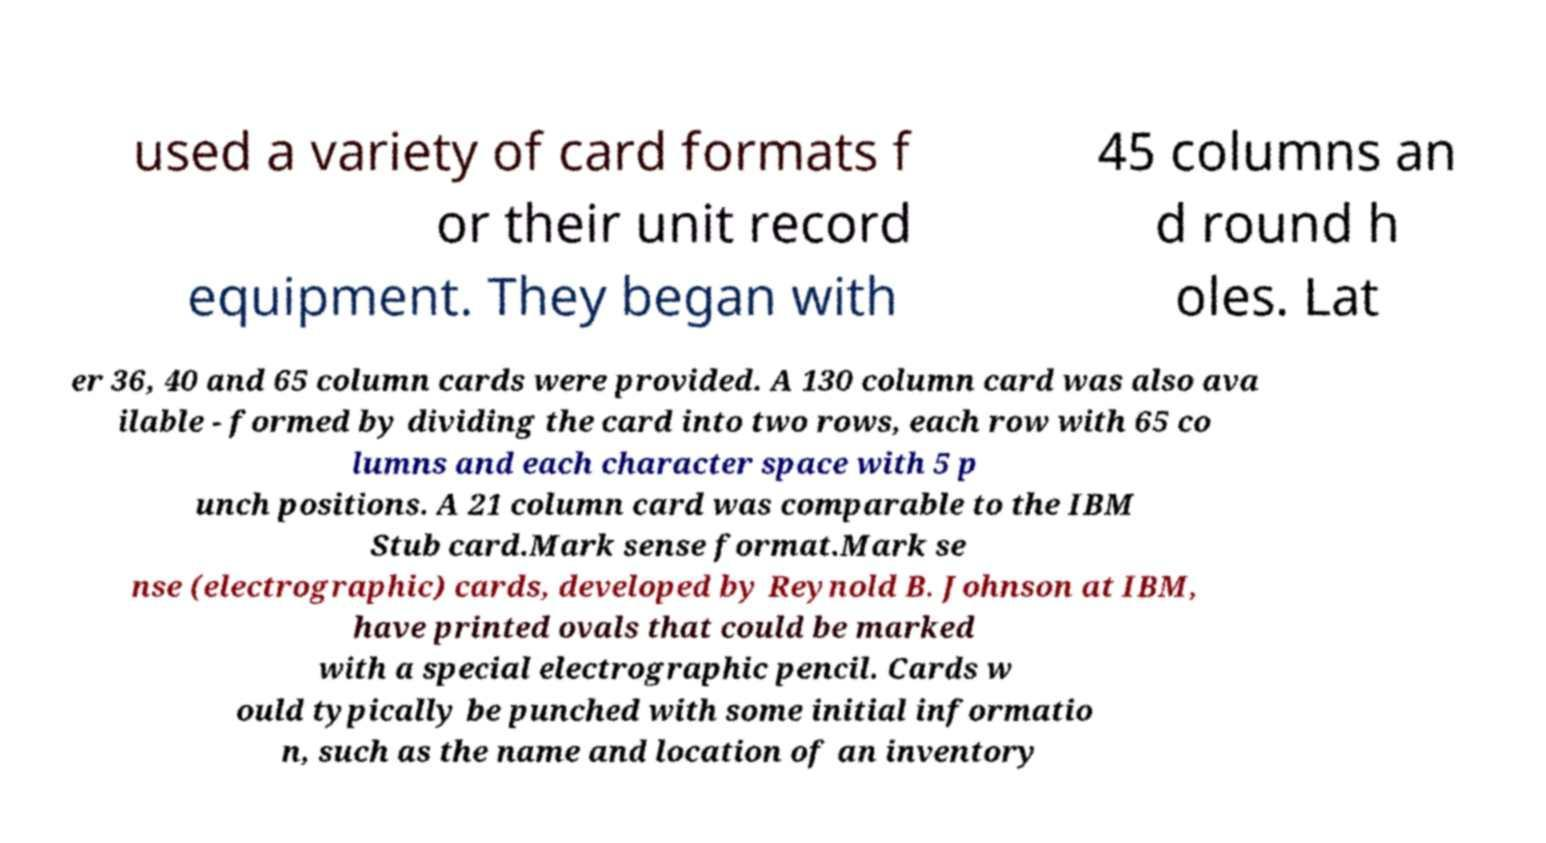Could you assist in decoding the text presented in this image and type it out clearly? used a variety of card formats f or their unit record equipment. They began with 45 columns an d round h oles. Lat er 36, 40 and 65 column cards were provided. A 130 column card was also ava ilable - formed by dividing the card into two rows, each row with 65 co lumns and each character space with 5 p unch positions. A 21 column card was comparable to the IBM Stub card.Mark sense format.Mark se nse (electrographic) cards, developed by Reynold B. Johnson at IBM, have printed ovals that could be marked with a special electrographic pencil. Cards w ould typically be punched with some initial informatio n, such as the name and location of an inventory 